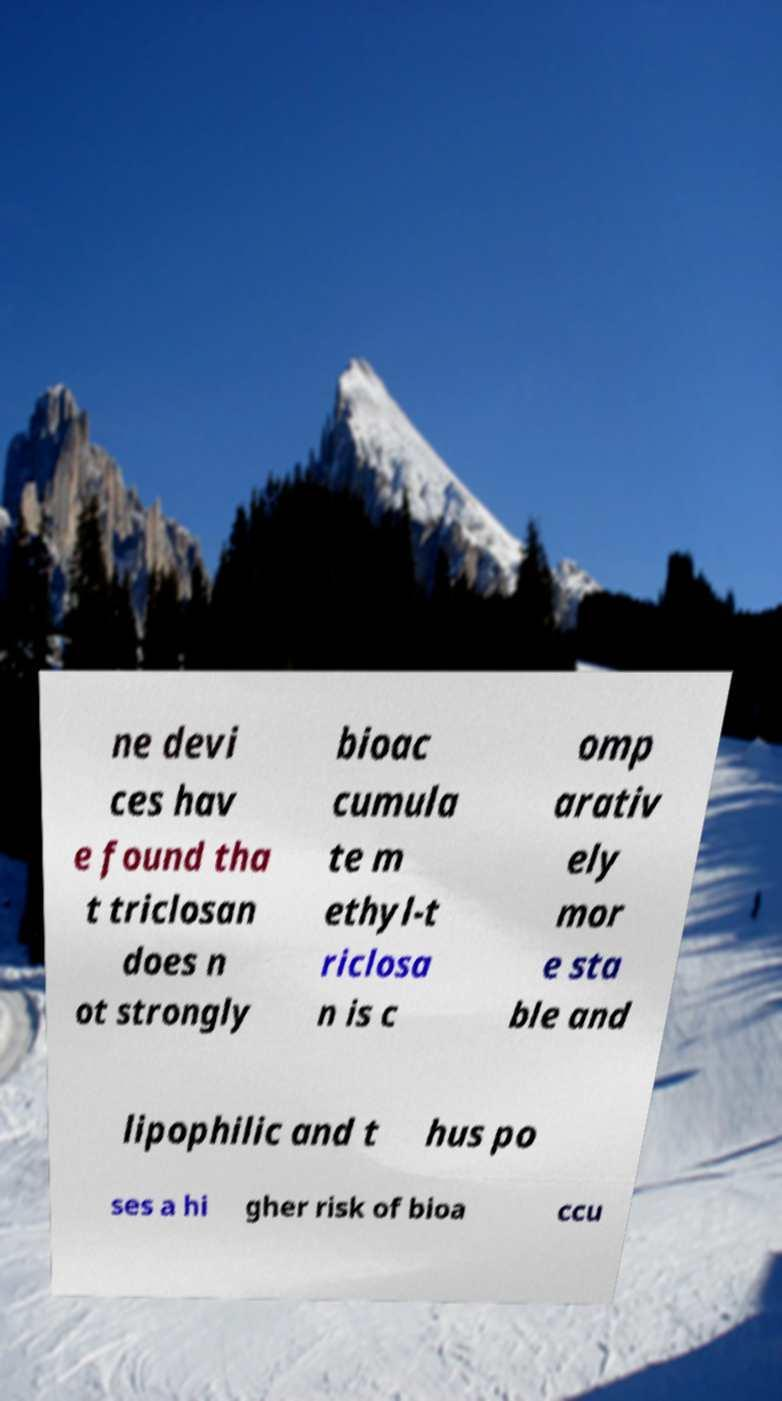Could you extract and type out the text from this image? ne devi ces hav e found tha t triclosan does n ot strongly bioac cumula te m ethyl-t riclosa n is c omp arativ ely mor e sta ble and lipophilic and t hus po ses a hi gher risk of bioa ccu 